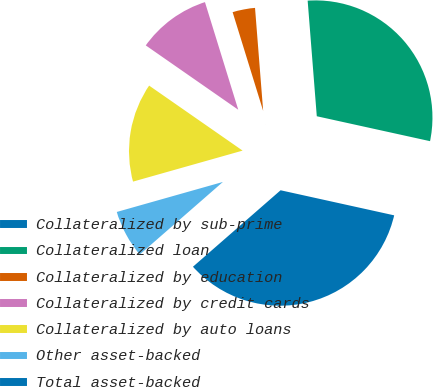Convert chart. <chart><loc_0><loc_0><loc_500><loc_500><pie_chart><fcel>Collateralized by sub-prime<fcel>Collateralized loan<fcel>Collateralized by education<fcel>Collateralized by credit cards<fcel>Collateralized by auto loans<fcel>Other asset-backed<fcel>Total asset-backed<nl><fcel>0.01%<fcel>29.7%<fcel>3.52%<fcel>10.55%<fcel>14.06%<fcel>7.03%<fcel>35.12%<nl></chart> 